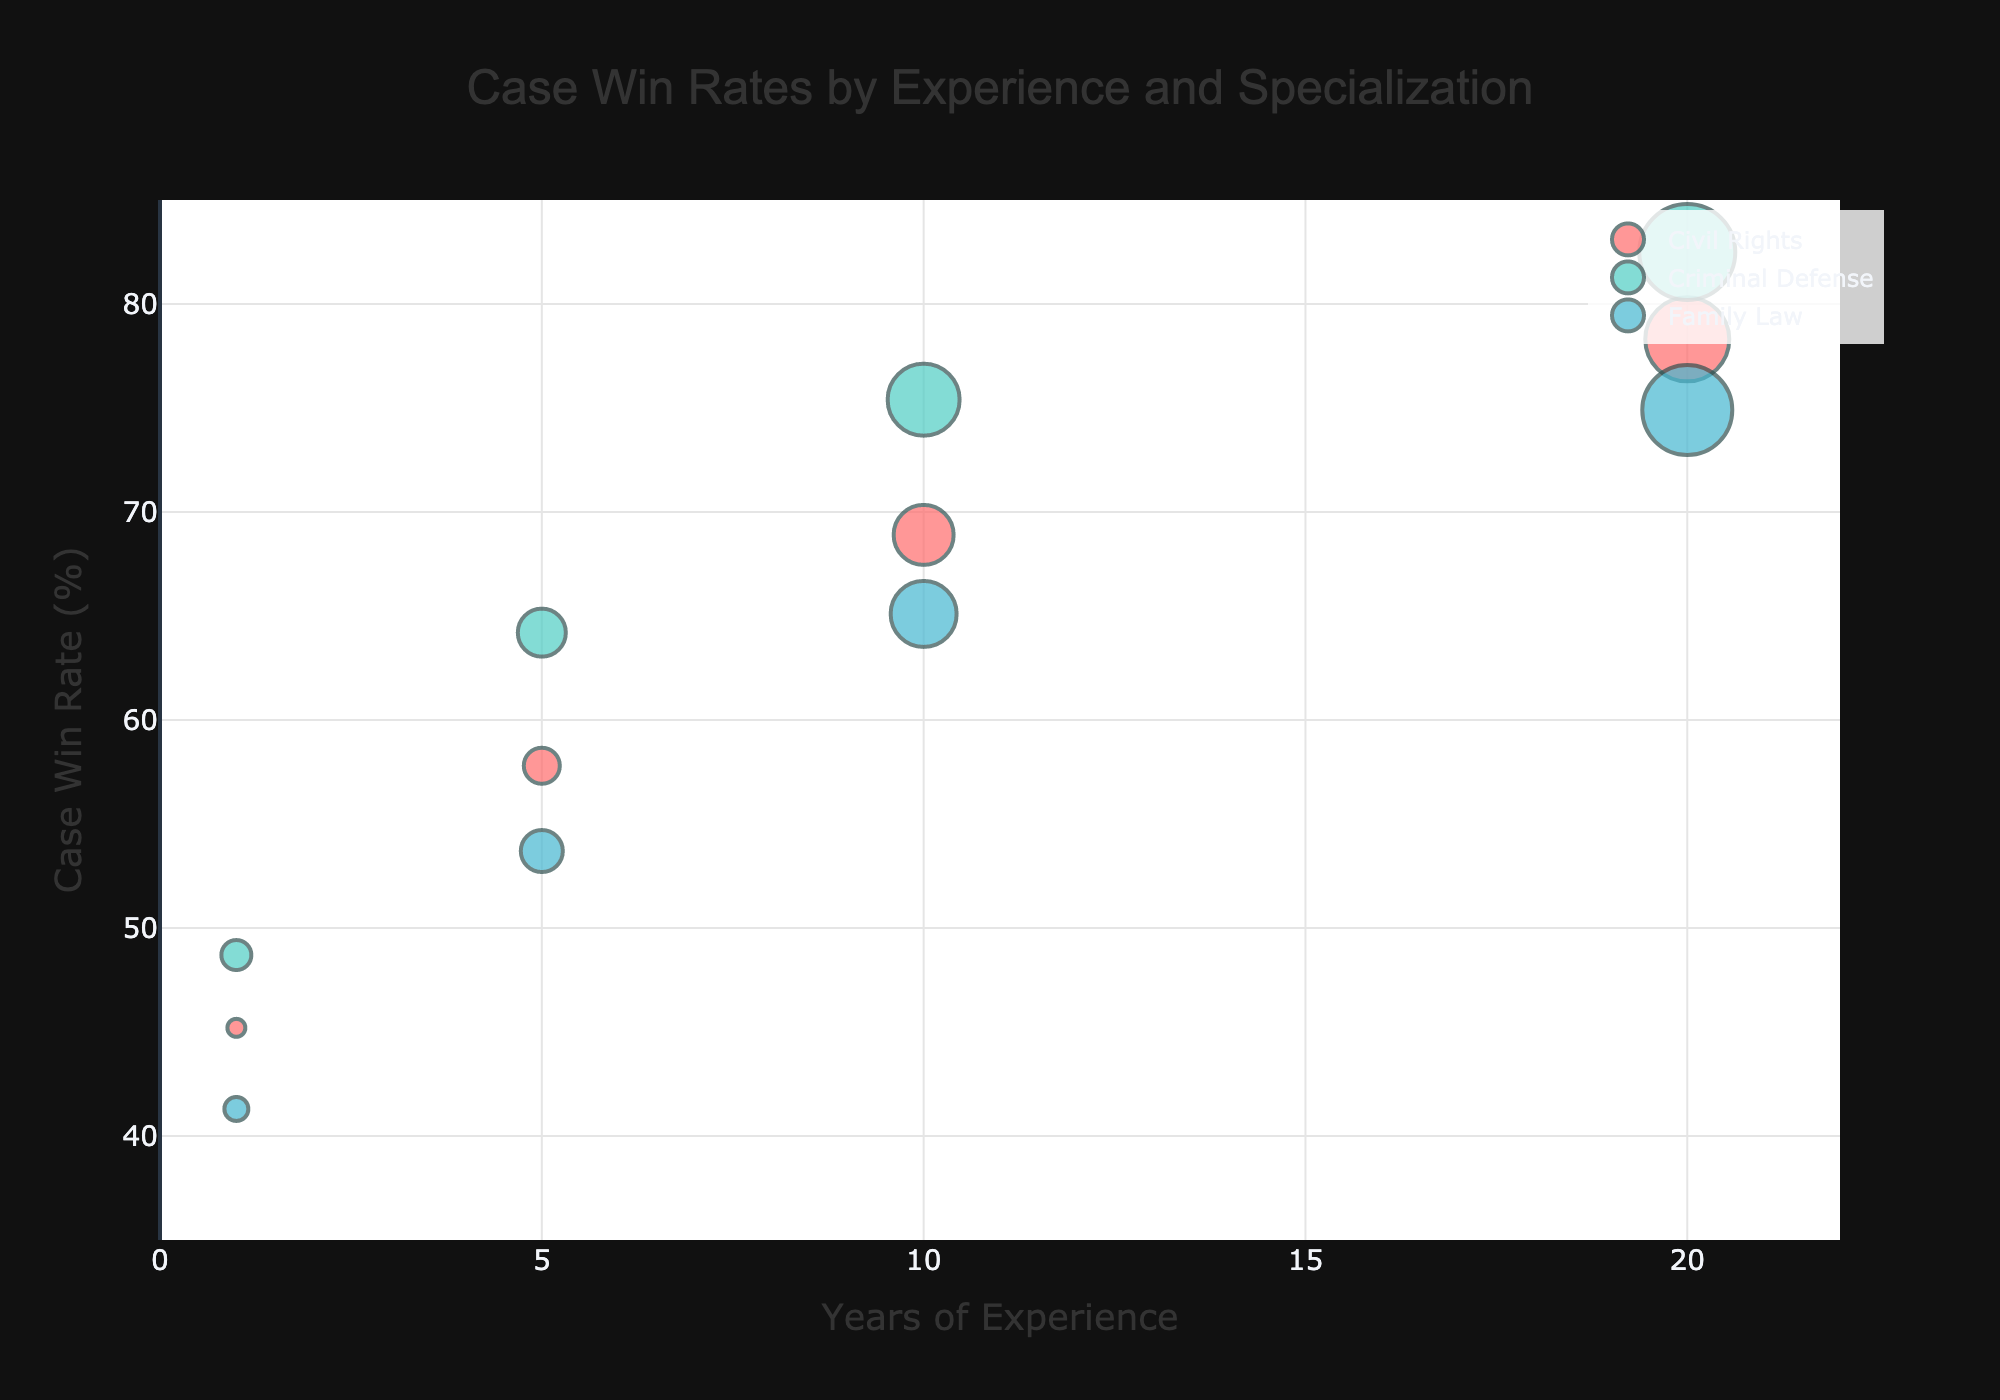What is the title of the bubble chart? The title is located at the top center of the chart and is typically in larger font. In this case, it reads "Case Win Rates by Experience and Specialization"
Answer: Case Win Rates by Experience and Specialization What are the axes titles in the chart? The horizontal axis title is labeled "Years of Experience" and the vertical axis title is labeled "Case Win Rate (%)". These titles provide the context for interpreting the data points.
Answer: Years of Experience, Case Win Rate (%) How do the win rates of Civil Rights lawyers change with more years of experience? Look at the data points for Civil Rights and observe the trend in Case Win Rate as Years of Experience increases. The win rate starts at 45.2% with 1 year, 57.8% with 5 years, 68.9% with 10 years, and 78.3% with 20 years.
Answer: Increases Which specialization has the highest win rate at 10 years of experience? Check the data points at 10 years of experience for each specialization. Criminal Defense has the highest win rate at 75.4%.
Answer: Criminal Defense What is the Case Win Rate for Family Law with 1 year of experience? Locate the Family Law data point at 1 year of experience and note the Case Win Rate value, which is 41.3%.
Answer: 41.3% How does the size of the bubbles reflect the number of law firms? The larger the bubble, the greater the number of law firms. Each bubble's size is proportional to the number of law firms, as indicated by the Bubble_Size_Law_Firms column in the data.
Answer: Proportional to the number of law firms For the specialization with the least experienced lawyers, what is their win rate? The least experienced group is those with 1 year of experience. Among these, Family Law has the lowest win rate at 41.3%.
Answer: 41.3% What is the collective trend for all specializations in terms of win rate as experience increases? As the years of experience increase for all specializations, the Case Win Rate generally increases. This can be observed by examining the bubbles for each specialization at different experience intervals.
Answer: Increasing trend Which specialization has the highest consistency in win rates as experience changes? By comparing the spread of Case Win Rate values across different levels of experience, Criminal Defense seems to have the most consistent trend, gradually increasing from 48.7% to 82.5%.
Answer: Criminal Defense Do Civil Rights lawyers with 5 years of experience have a higher win rate compared to Family Law lawyers with 10 years of experience? Compare the Case Win Rates for Civil Rights lawyers at 5 years and Family Law lawyers at 10 years. Civil Rights shows 57.8% at 5 years, and Family Law shows 65.1% at 10 years.
Answer: No, 65.1% is higher than 57.8% 